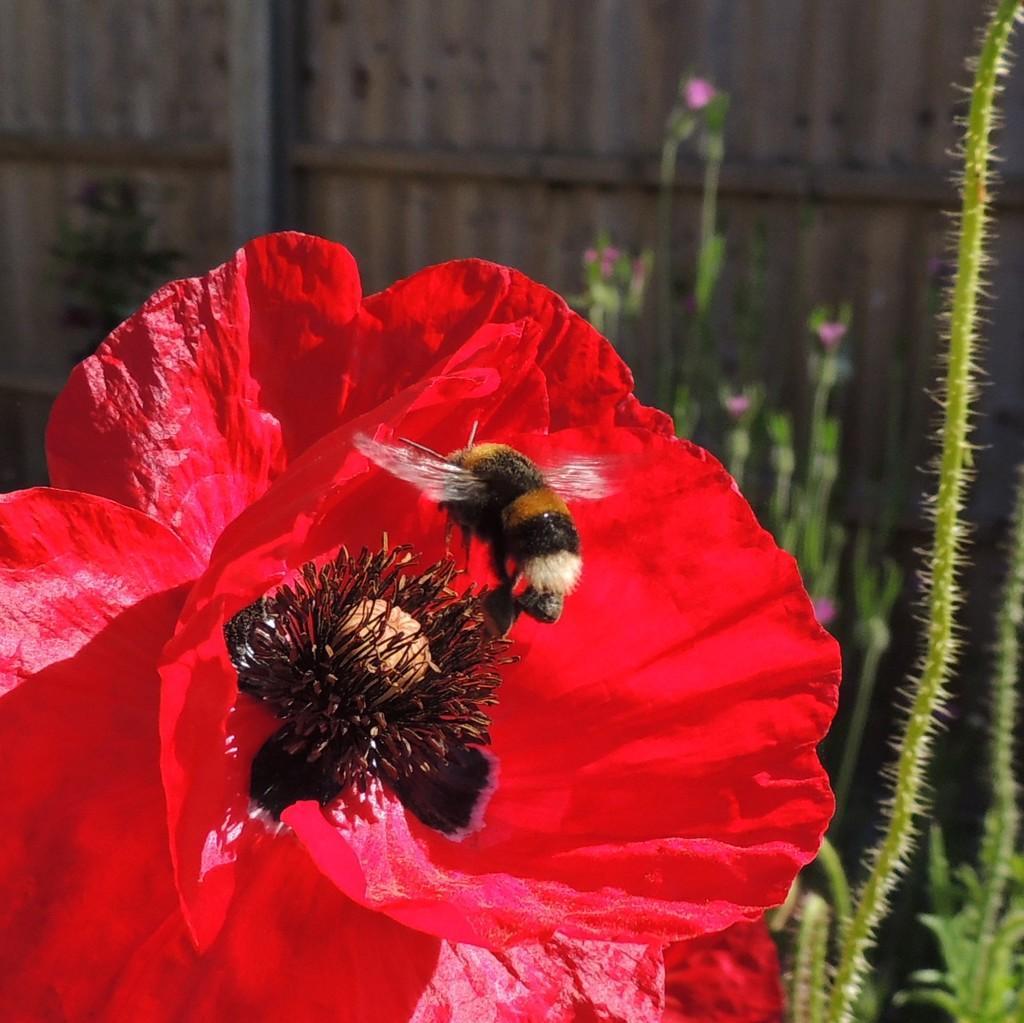In one or two sentences, can you explain what this image depicts? In the center of the image there is a fly on the flower. In the background we can see plants and wall. 